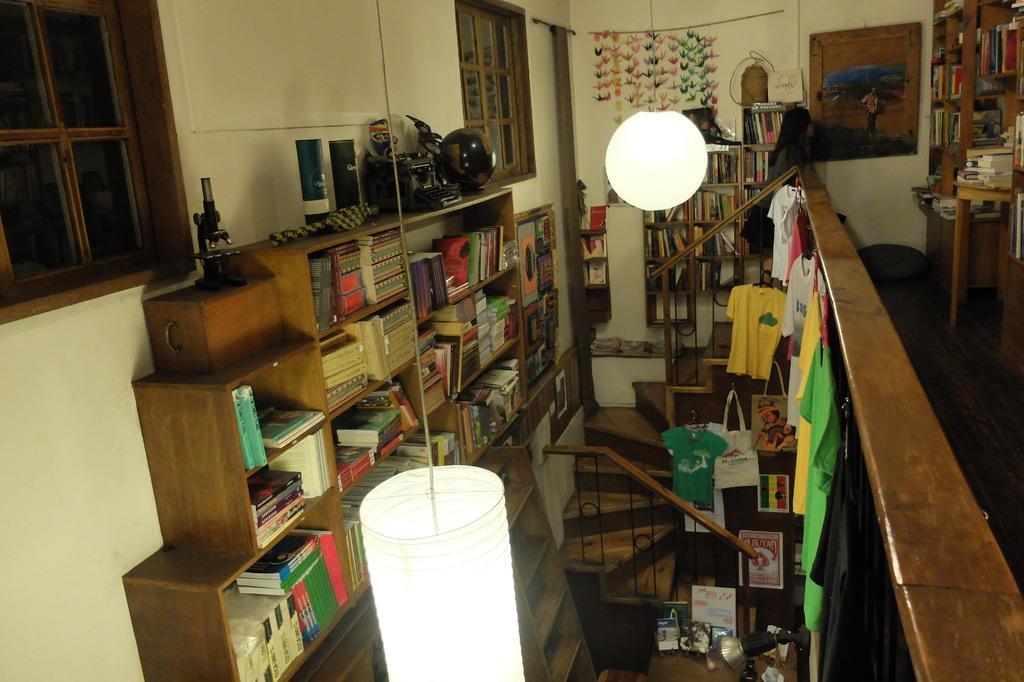Could you give a brief overview of what you see in this image? In that racks there are books. Above that racks there are things. Left side of the image we can see windows and wall. Middle of the image we can see decorative object, lights, steps, clothes, posters, bag, lamp and things. Picture is on the wall. 